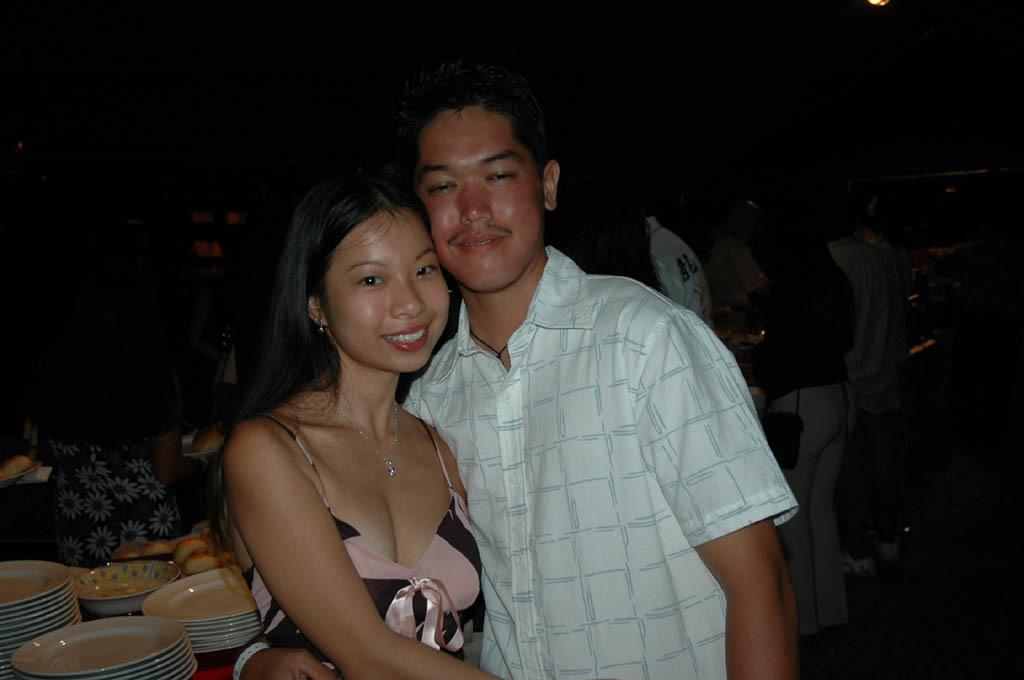How many people are present in the image? There is a man and a woman in the image, along with many people in the background. What are the man and the woman wearing in the image? Both the man and the woman are wearing chains in the image. What can be seen on the platform in the image? There are plates and other items on the platform in the image. What is the color of the background in the image? The background of the image is dark. What type of comb is the man using to paint the stage in the image? There is no comb, paint, or stage present in the image. 